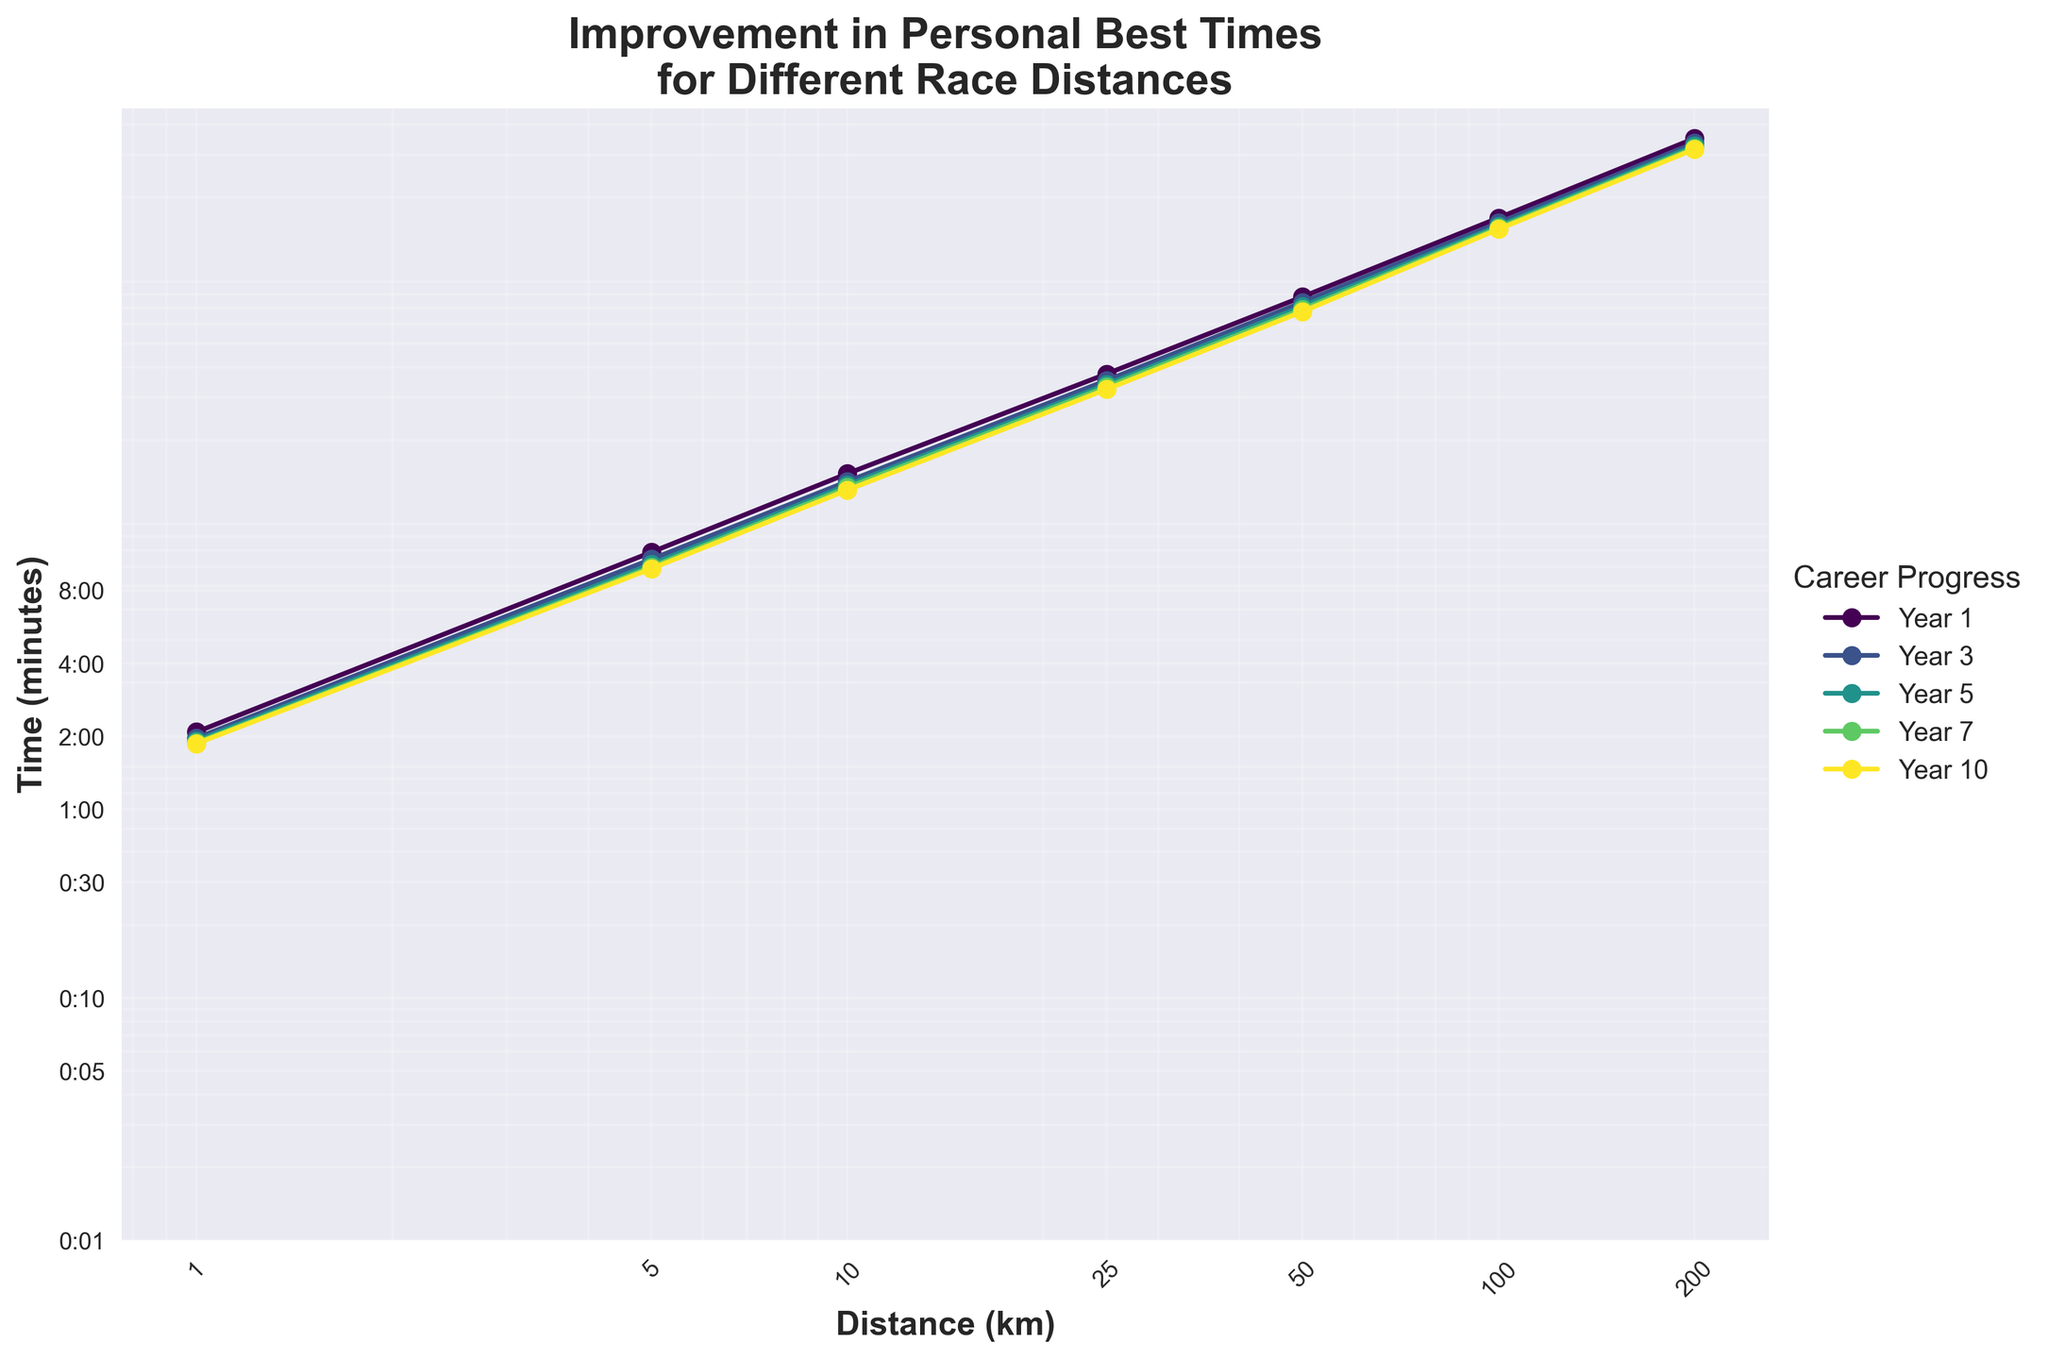What is the trend in personal best times for the 1 km distance over the 10-year period? The times for the 1 km distance over the years decrease as follows: Year 1 (2:05), Year 3 (1:58), Year 5 (1:55), Year 7 (1:53), Year 10 (1:52). Each year shows improvement in the personal best times.
Answer: Decreasing trend How much improvement is there in the 5 km distance from Year 1 to Year 10? The time for the 5 km distance in Year 1 is 11:30 (minutes:seconds) and in Year 10 is 9:50. To find the improvement, convert the times to seconds: Year 1 (690 seconds), Year 10 (590 seconds). The improvement is 690 - 590 = 100 seconds, or 1 minute and 40 seconds.
Answer: 100 seconds (1:40) Which year shows the greatest improvement for the 50 km distance compared to the previous measurement? For the 50 km distances, the times are: Year 1 (2:10:00), Year 3 (2:03:30), Year 5 (1:58:45), Year 7 (1:55:30), and Year 10 (1:53:00). Convert times to minutes and calculate the differences: Year 1 to Year 3 (410.5 minutes - 390 minutes = 20.5 minutes), Year 3 to Year 5 (390 minutes - 374.75 minutes = 15.25 minutes), Year 5 to Year 7 (374.75 minutes - 355.5 minutes = 19.25 minutes), Year 7 to Year 10 (355.5 minutes - 343 minutes = 12.5 minutes). Year 1 to Year 3 shows the greatest improvement of 20.5 minutes.
Answer: Year 1 to Year 3 Is the improvement rate for personal best times consistent across all distances over the 10-year period? By analyzing the slope of the lines over successive years for all distances on a log-log scale, it can be seen that the rate of improvement is not consistent. Shorter distances tend to improve more gradually, while longer distances show more significant initial improvements that taper off over time.
Answer: No What is the personal best time for the 10 km race in Year 7? According to the data, the personal best time for the 10 km distance in Year 7 is 21:15 minutes (21 minutes and 15 seconds).
Answer: 21:15 How does the personal best time for the 100 km distance in Year 10 compare to Year 5? The personal best time for the 100 km distance in Year 10 is 4:07:00, whereas in Year 5 it is 4:15:00. By converting to minutes: Year 10 (247 minutes), Year 5 (255 minutes). The difference is 255 - 247 = 8 minutes improvement.
Answer: Improved by 8 minutes Are there any distances where the personal best time did not improve between two consecutive measurement years? Comparing the times between each consecutive year for all distances shows that every distance improved from one year to the next.
Answer: No, all distances show improvement What is the average personal best time for the 25 km distance over the 10-year period? The times for 25 km are Year 1 (1:02:30), Year 3 (58:45), Year 5 (56:30), Year 7 (55:15), Year 10 (54:00). Convert times to minutes: Year 1 (62.5), Year 3 (58.75), Year 5 (56.5), Year 7 (55.25), Year 10 (54). The average is (62.5 + 58.75 + 56.5 + 55.25 + 54) / 5 = 57. This means the average personal best time is approximately 57 minutes.
Answer: 57 minutes Which distance shows the least improvement in personal best times from Year 1 to Year 10 as a percentage? Calculate the percentage improvement for each distance by comparing Year 1 and Year 10 times: 1 km (2:05 to 1:52, 10.4% improvement), 5 km (11:30 to 9:50, 14.8% improvement), 10 km (24:15 to 20:45, 14.3% improvement), 25 km (1:02:30 to 54:00, 13.6% improvement), 50 km (2:10:00 to 1:53:00, 13.1% improvement), 100 km (4:35:00 to 4:07:00, 10.2% improvement), 200 km (9:45:00 to 8:48:00, 9.8% improvement). The least percentage improvement is for the 200 km distance with 9.8%.
Answer: 200 km (9.8%) 